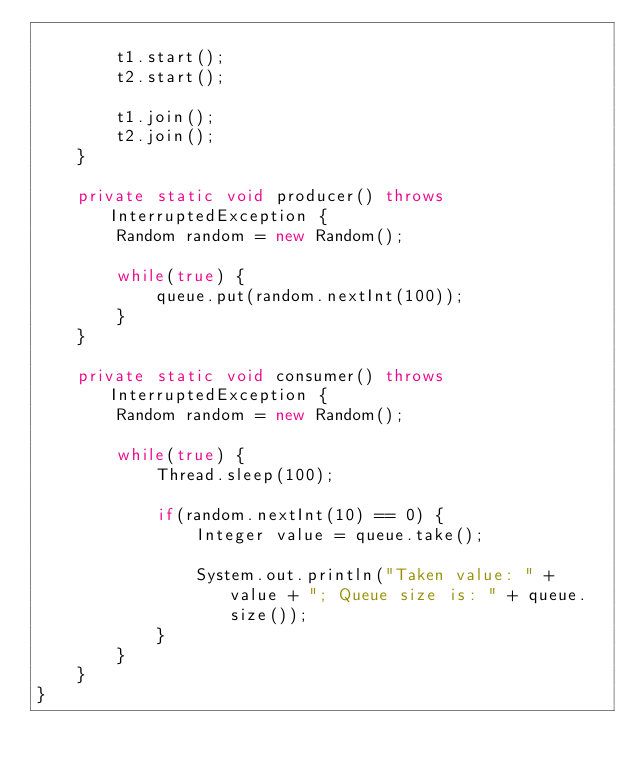Convert code to text. <code><loc_0><loc_0><loc_500><loc_500><_Java_>		
		t1.start();
		t2.start();
		
		t1.join();
		t2.join();
	}
	
	private static void producer() throws InterruptedException {
		Random random = new Random();
		
		while(true) {
			queue.put(random.nextInt(100));
		}
	}
	
	private static void consumer() throws InterruptedException {
		Random random = new Random();
		
		while(true) {
			Thread.sleep(100);
			
			if(random.nextInt(10) == 0) {
				Integer value = queue.take();
				
				System.out.println("Taken value: " + value + "; Queue size is: " + queue.size());
			}
		}
	}
}
</code> 